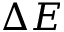Convert formula to latex. <formula><loc_0><loc_0><loc_500><loc_500>\Delta E</formula> 